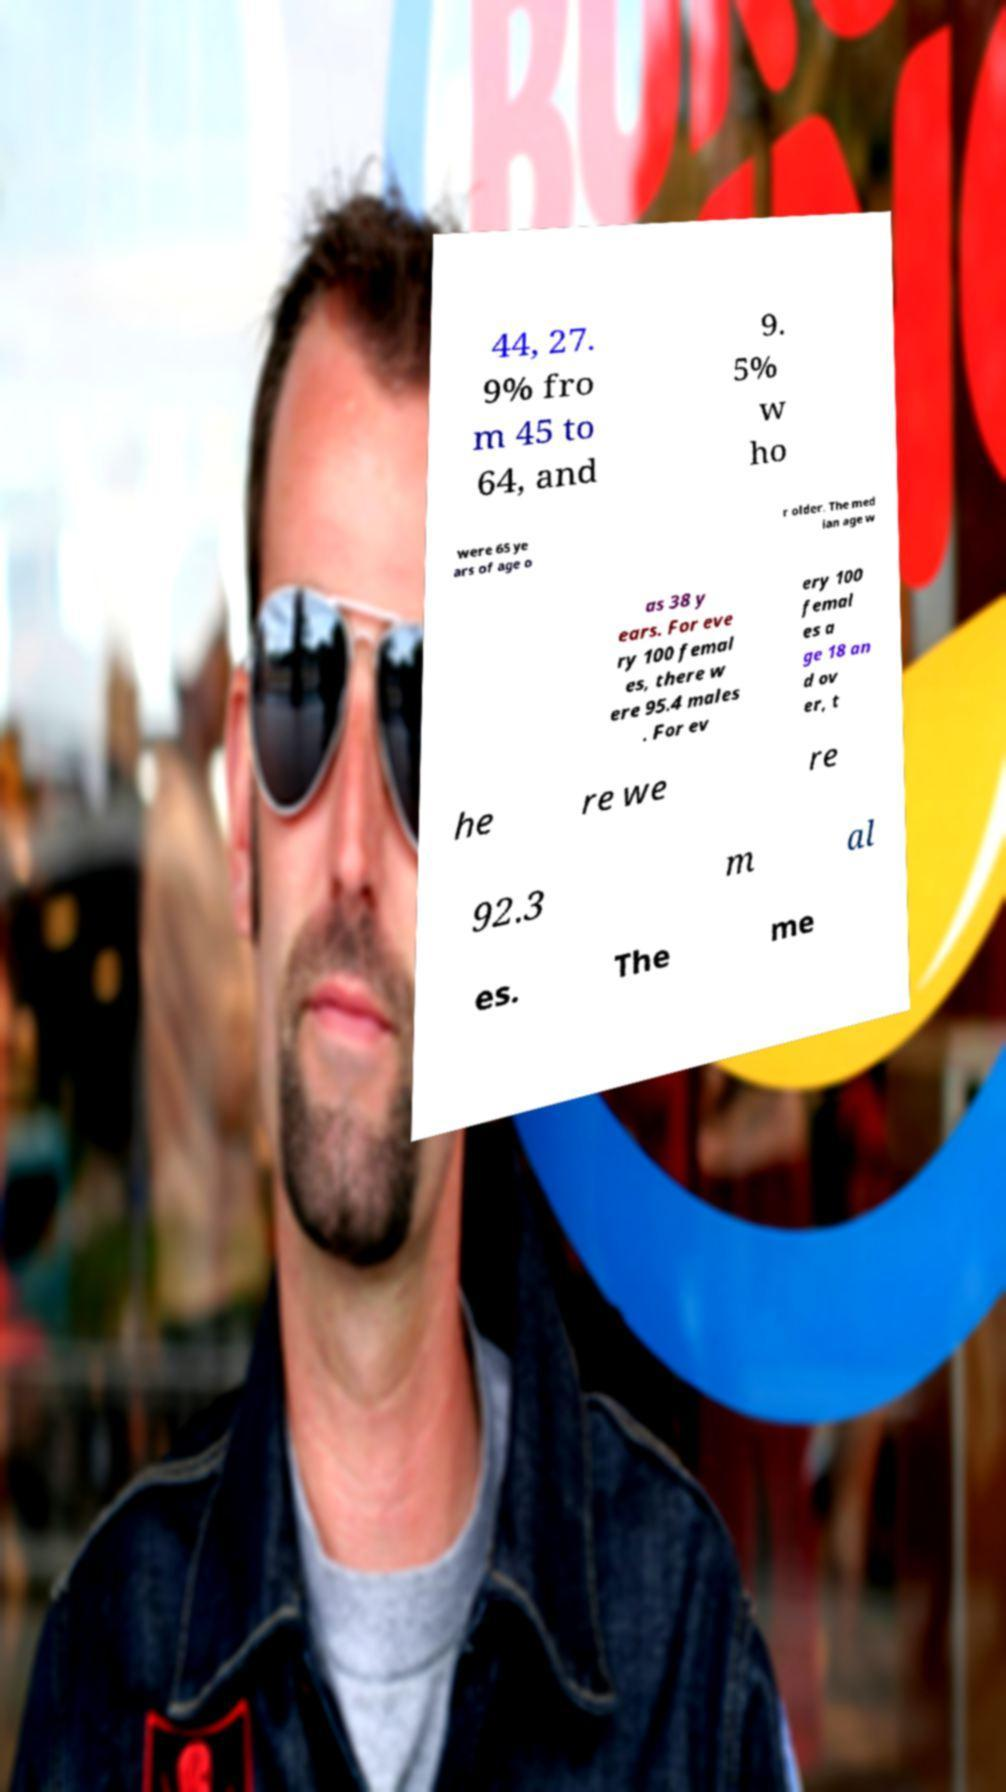Can you accurately transcribe the text from the provided image for me? 44, 27. 9% fro m 45 to 64, and 9. 5% w ho were 65 ye ars of age o r older. The med ian age w as 38 y ears. For eve ry 100 femal es, there w ere 95.4 males . For ev ery 100 femal es a ge 18 an d ov er, t he re we re 92.3 m al es. The me 